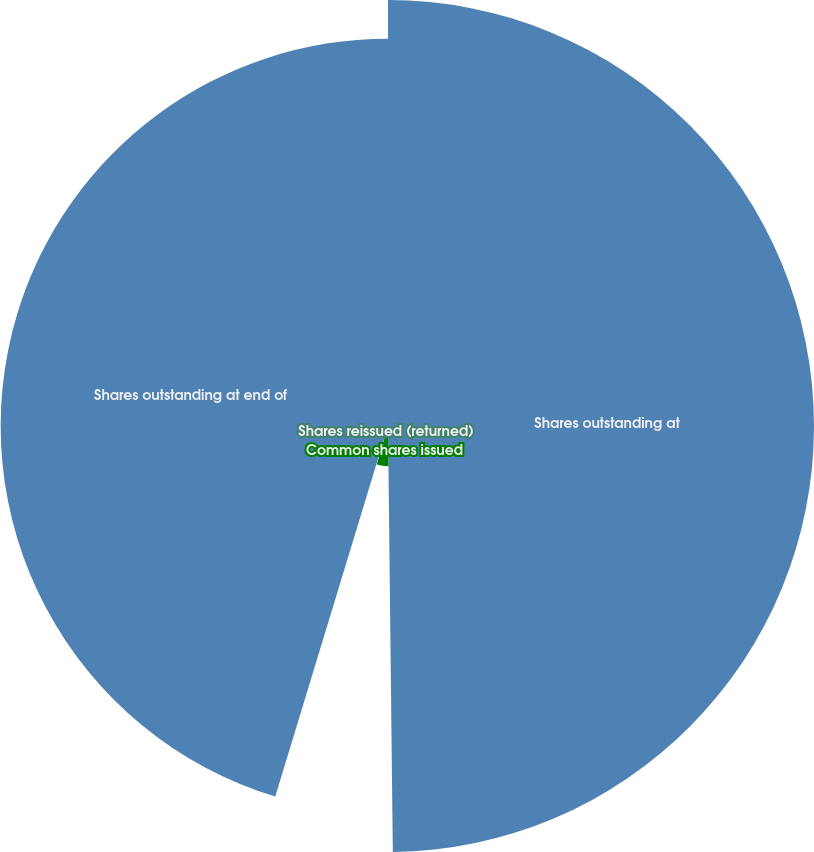<chart> <loc_0><loc_0><loc_500><loc_500><pie_chart><fcel>Shares outstanding at<fcel>Common shares issued<fcel>Shares reissued (returned)<fcel>Shares outstanding at end of<nl><fcel>49.82%<fcel>4.7%<fcel>0.18%<fcel>45.3%<nl></chart> 